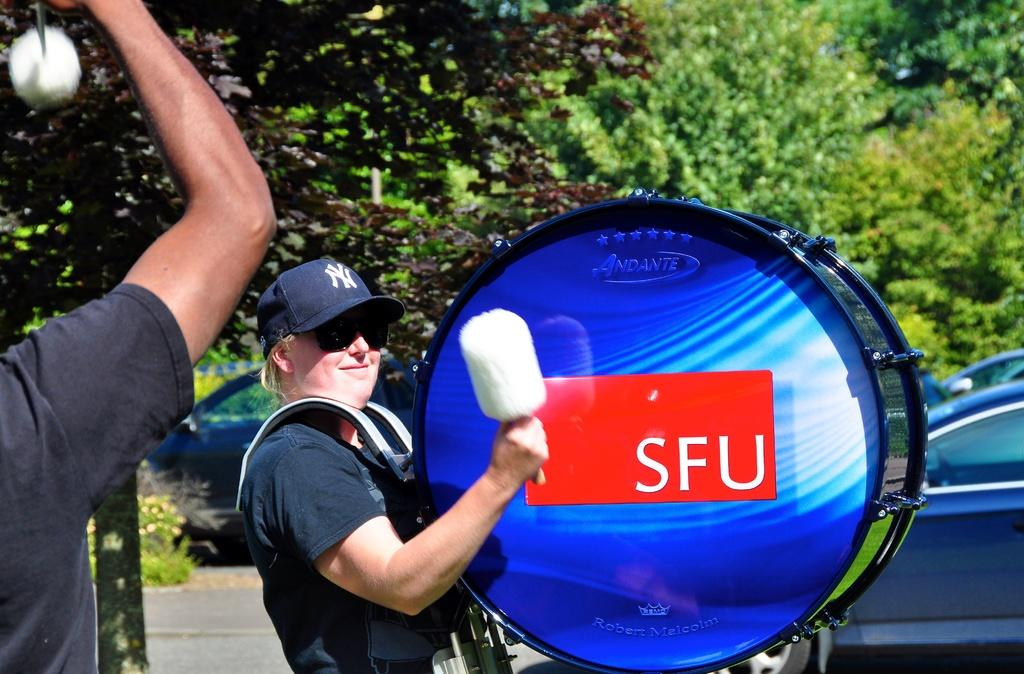What activity is the person in the image engaged in? There is a person playing a drum in the image. What else can be seen in the image besides the person playing the drum? There is a vehicle visible in the image. What type of natural vegetation is present in the image? There are trees present in the image. What type of scarecrow can be seen kicking a soccer ball in the image? There is no scarecrow or soccer ball present in the image. What type of sand can be seen in the image? There is no sand present in the image. 